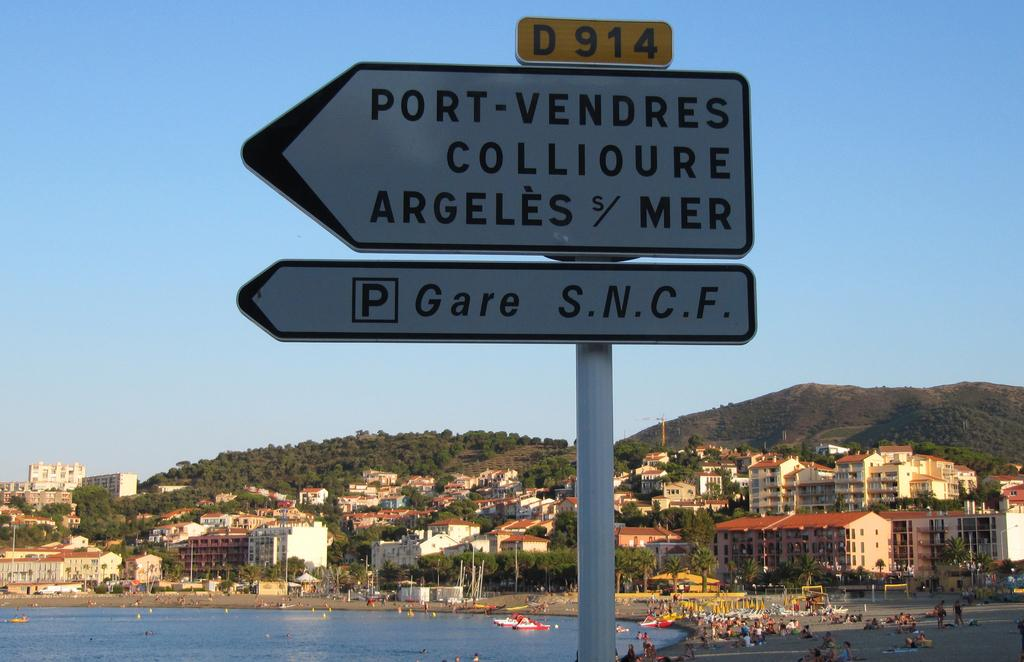Provide a one-sentence caption for the provided image. A sign pointing to Port-Vendres Collioure Argeles Mer. 